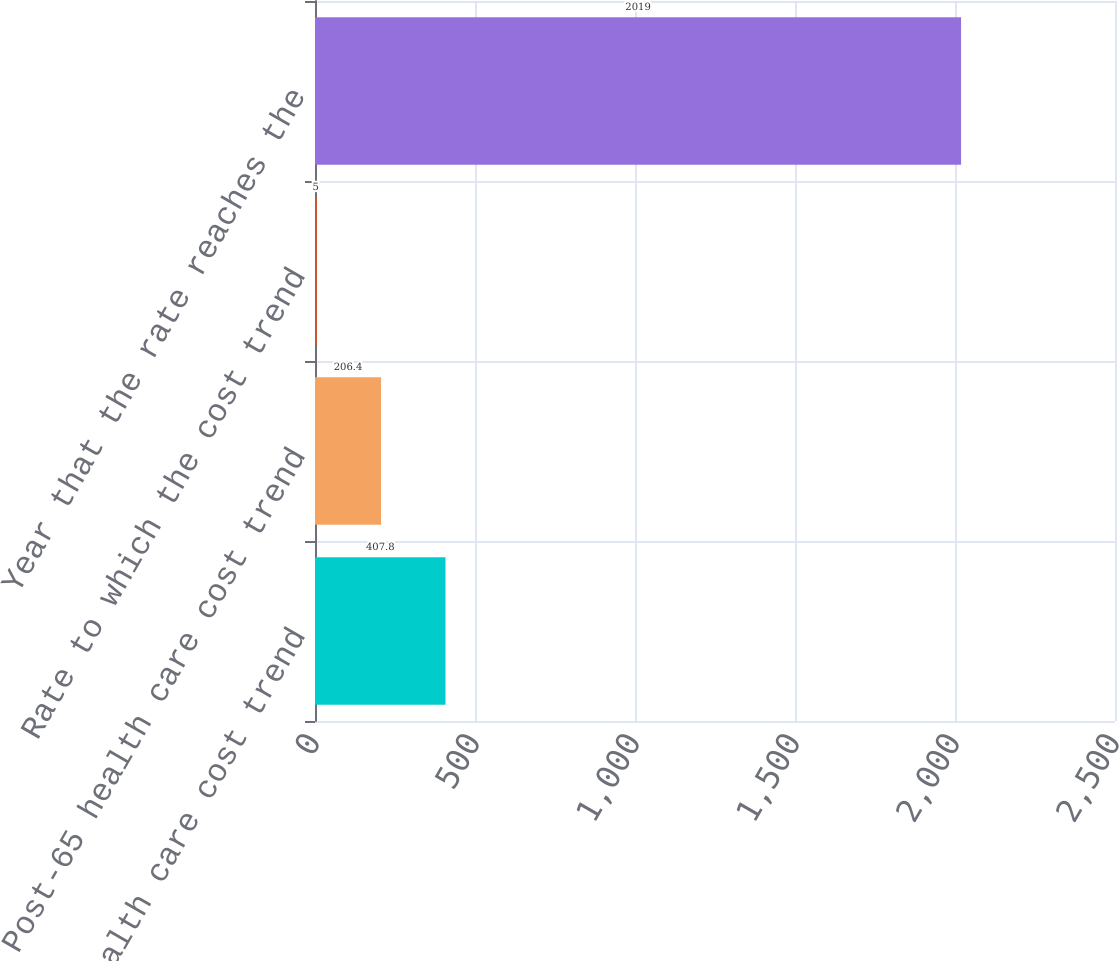Convert chart. <chart><loc_0><loc_0><loc_500><loc_500><bar_chart><fcel>Pre-65 health care cost trend<fcel>Post-65 health care cost trend<fcel>Rate to which the cost trend<fcel>Year that the rate reaches the<nl><fcel>407.8<fcel>206.4<fcel>5<fcel>2019<nl></chart> 